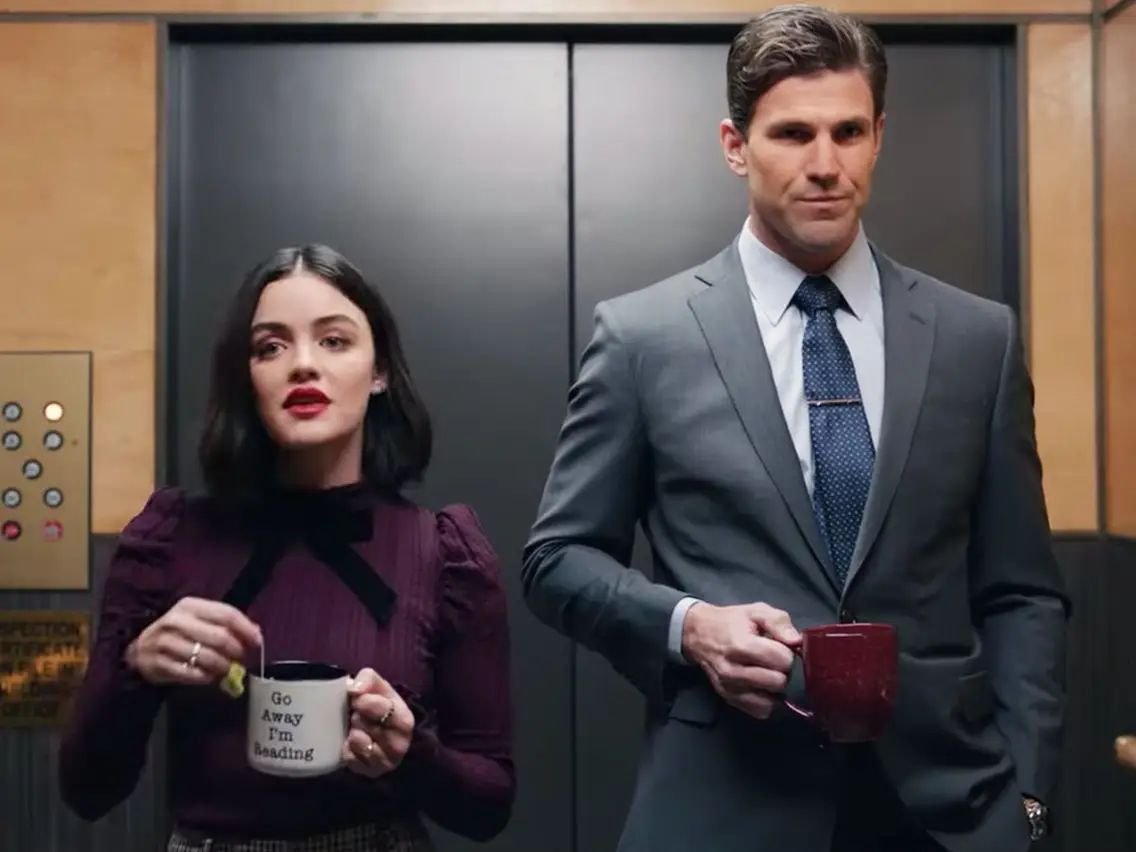Can you describe the mood and attire in this picture? The mood in the image seems quite contrasting between the two individuals. Lucy Hale's expression, with slightly widened eyes and raised eyebrows, conveys a sense of surprise or curiosity, and her attire—a sophisticated purple blouse with a bow—adds a touch of elegance and edginess. The man beside her, on the other hand, exhibits a more serious demeanor, emphasized by his impeccable gray suit and blue tie, further contributing to the image's dichotomy. 